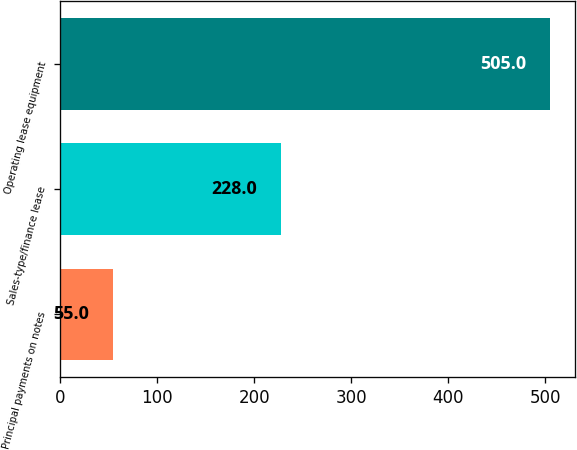<chart> <loc_0><loc_0><loc_500><loc_500><bar_chart><fcel>Principal payments on notes<fcel>Sales-type/finance lease<fcel>Operating lease equipment<nl><fcel>55<fcel>228<fcel>505<nl></chart> 